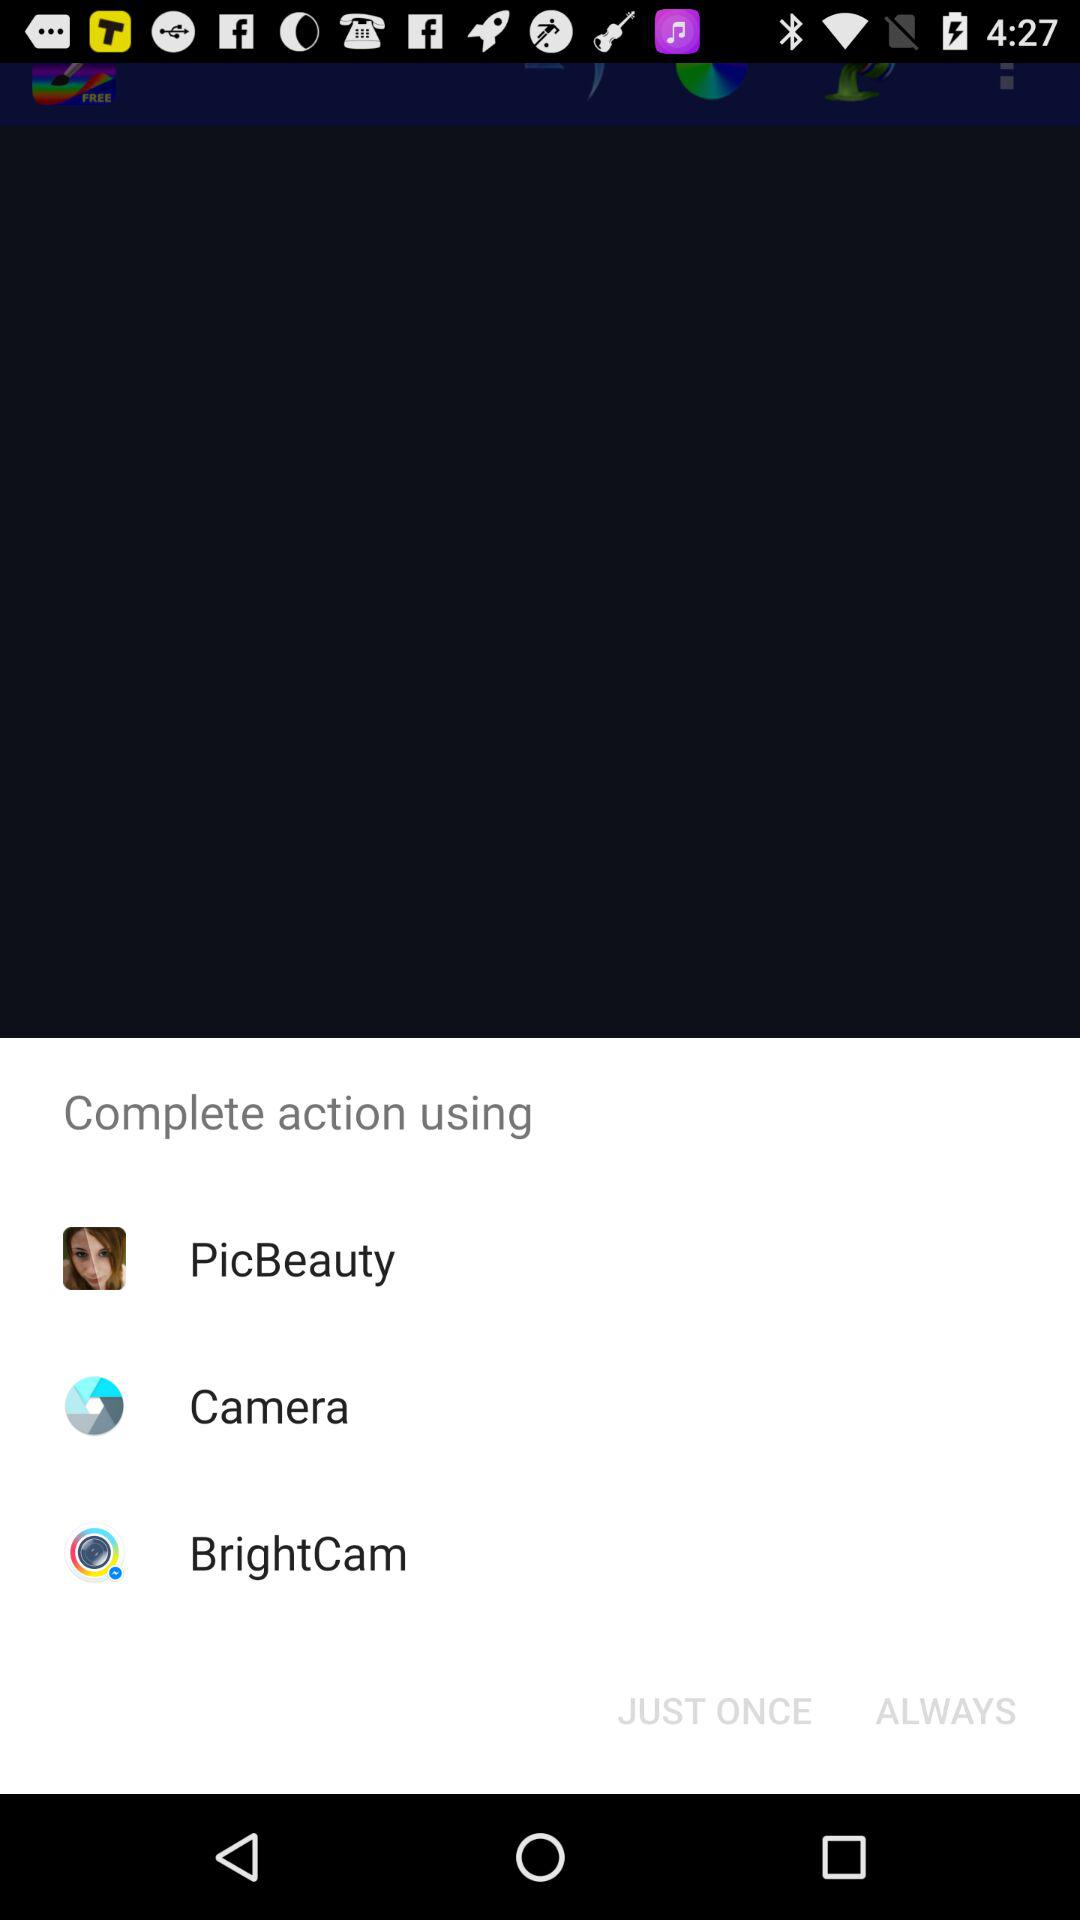What are the options to complete the action? The options are "PicBeauty", "Camera" and "BrightCam". 